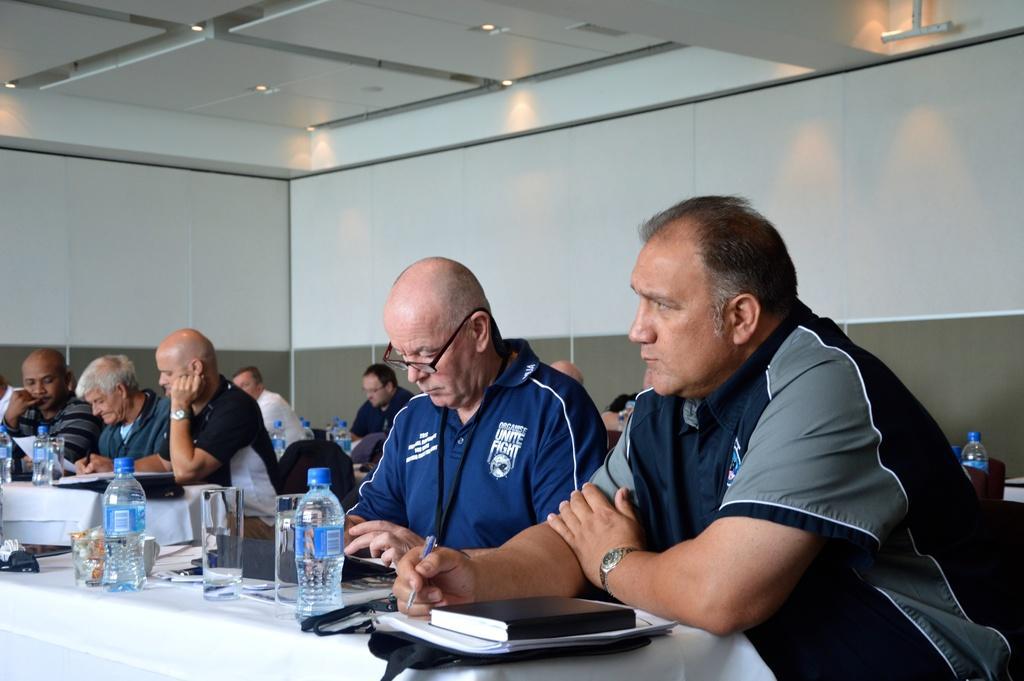Could you give a brief overview of what you see in this image? In this image we can see a group of men sitting. In that two men are holding the pens. We can also see the tables containing some bottles, glasses, books, papers and some objects on them. On the backside we can see a wall and a roof with some ceiling lights. 